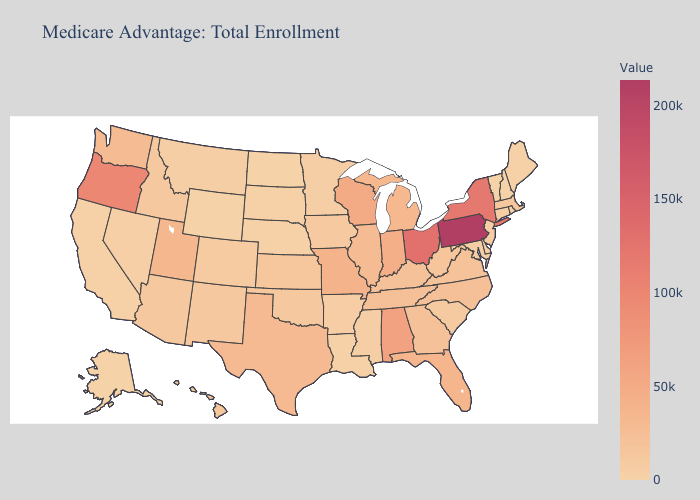Which states have the highest value in the USA?
Short answer required. Pennsylvania. Among the states that border North Carolina , does South Carolina have the lowest value?
Write a very short answer. Yes. 